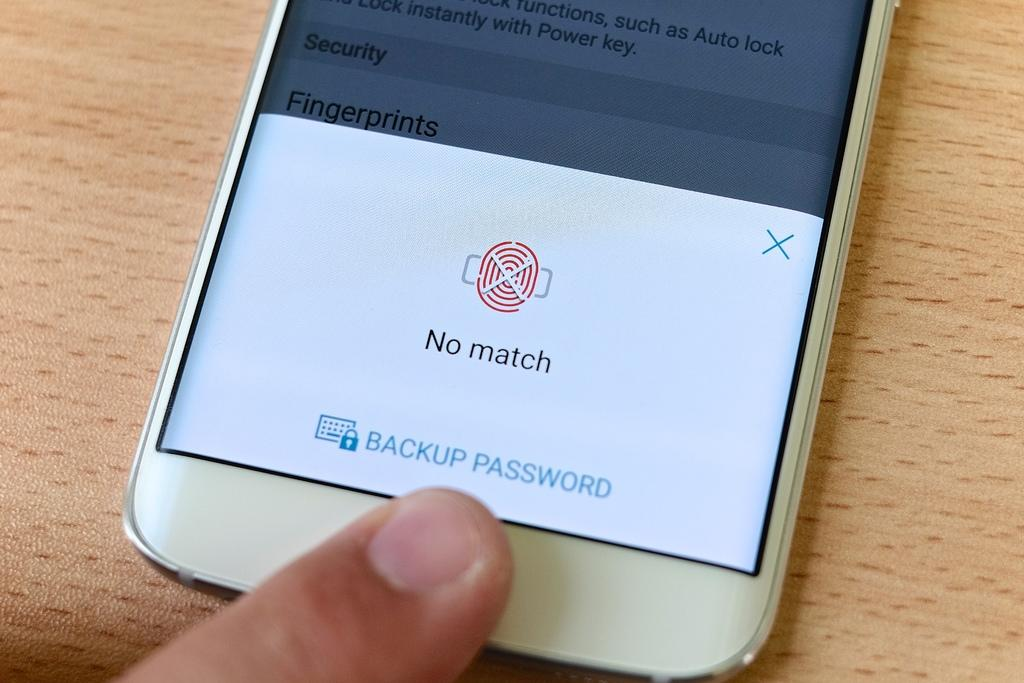<image>
Create a compact narrative representing the image presented. A mobile phone says there is no match to the fingerprint belonging to the finger next to it. 